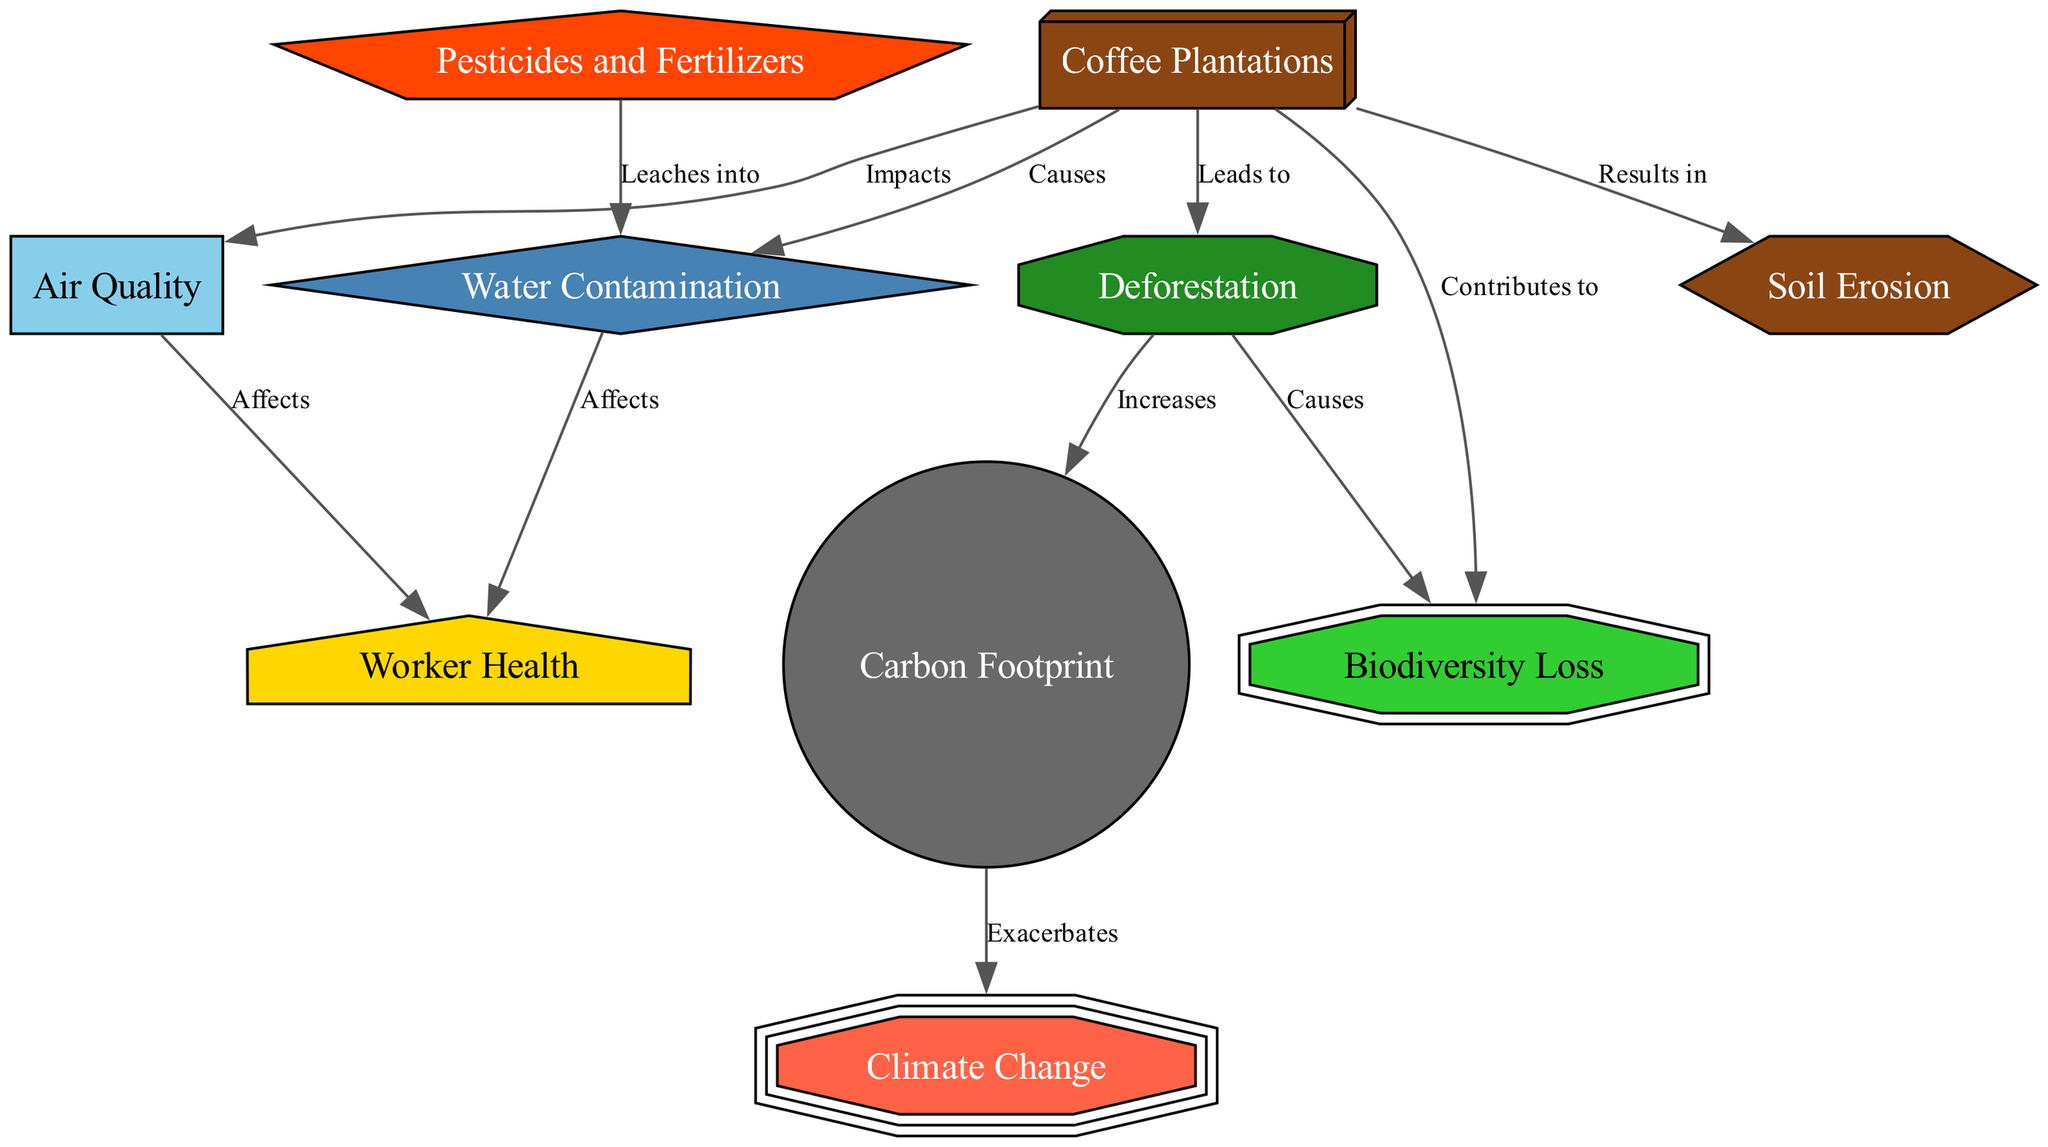What is the first node in the diagram? The diagram begins with the node "Coffee Plantations". This can be found at the top since it serves as the primary factor for impacts below it.
Answer: Coffee Plantations How many nodes are there in total? By counting all unique nodes in the diagram, there are eleven nodes, representing various environmental impacts and aspects related to coffee plantations.
Answer: 11 What does deforestation lead to? According to the diagram, deforestation leads to biodiversity loss as indicated by the directional edge from "deforestation" to "biodiversityLoss" with the label "Causes".
Answer: Biodiversity Loss Which factor impacts worker health? The diagram shows that both "Water Contamination" and "Air Quality" affect worker health. This means worker health is influenced by both environmental factors as illustrated in the edges leading to "workerHealth".
Answer: Water Contamination, Air Quality What does the link from carbon footprint to climate change indicate? There is a connection labeled "Exacerbates" that suggests an increase in carbon footprint can worsen climate change, indicating a negative compounding impact.
Answer: Exacerbates How does pesticides relate to water contamination? The edge from "Pesticides and Fertilizers" to "Water Contamination" indicates that pesticides can leach into water systems, directly linking agricultural practices to environmental consequences.
Answer: Leaches into Which node results in soil erosion? The diagram indicates that soil erosion is a result of coffee plantations, as shown by the directional edge labeled "Results in" from "Coffee Plantations" to "Soil Erosion".
Answer: Coffee Plantations What effect does deforestation have on carbon footprint? The diagram states that deforestation increases the carbon footprint, as indicated by the label "Increases" on the edge from "Deforestation" to "Carbon Footprint".
Answer: Increases How many edges connect the nodes? By counting the connections (edges) shown in the diagram, one can observe there are ten edges indicating the relationships between different environmental impacts of coffee plantation practices.
Answer: 10 